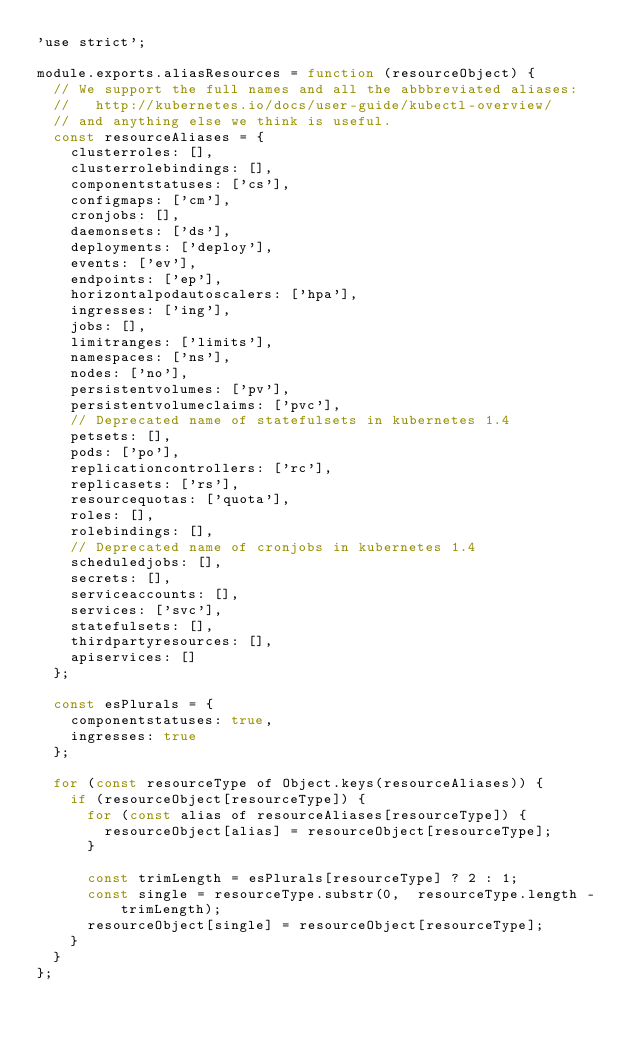<code> <loc_0><loc_0><loc_500><loc_500><_JavaScript_>'use strict';

module.exports.aliasResources = function (resourceObject) {
  // We support the full names and all the abbbreviated aliases:
  //   http://kubernetes.io/docs/user-guide/kubectl-overview/
  // and anything else we think is useful.
  const resourceAliases = {
    clusterroles: [],
    clusterrolebindings: [],
    componentstatuses: ['cs'],
    configmaps: ['cm'],
    cronjobs: [],
    daemonsets: ['ds'],
    deployments: ['deploy'],
    events: ['ev'],
    endpoints: ['ep'],
    horizontalpodautoscalers: ['hpa'],
    ingresses: ['ing'],
    jobs: [],
    limitranges: ['limits'],
    namespaces: ['ns'],
    nodes: ['no'],
    persistentvolumes: ['pv'],
    persistentvolumeclaims: ['pvc'],
    // Deprecated name of statefulsets in kubernetes 1.4
    petsets: [],
    pods: ['po'],
    replicationcontrollers: ['rc'],
    replicasets: ['rs'],
    resourcequotas: ['quota'],
    roles: [],
    rolebindings: [],
    // Deprecated name of cronjobs in kubernetes 1.4
    scheduledjobs: [],
    secrets: [],
    serviceaccounts: [],
    services: ['svc'],
    statefulsets: [],
    thirdpartyresources: [],
    apiservices: []
  };

  const esPlurals = {
    componentstatuses: true,
    ingresses: true
  };

  for (const resourceType of Object.keys(resourceAliases)) {
    if (resourceObject[resourceType]) {
      for (const alias of resourceAliases[resourceType]) {
        resourceObject[alias] = resourceObject[resourceType];
      }

      const trimLength = esPlurals[resourceType] ? 2 : 1;
      const single = resourceType.substr(0,  resourceType.length - trimLength);
      resourceObject[single] = resourceObject[resourceType];
    }
  }
};
</code> 